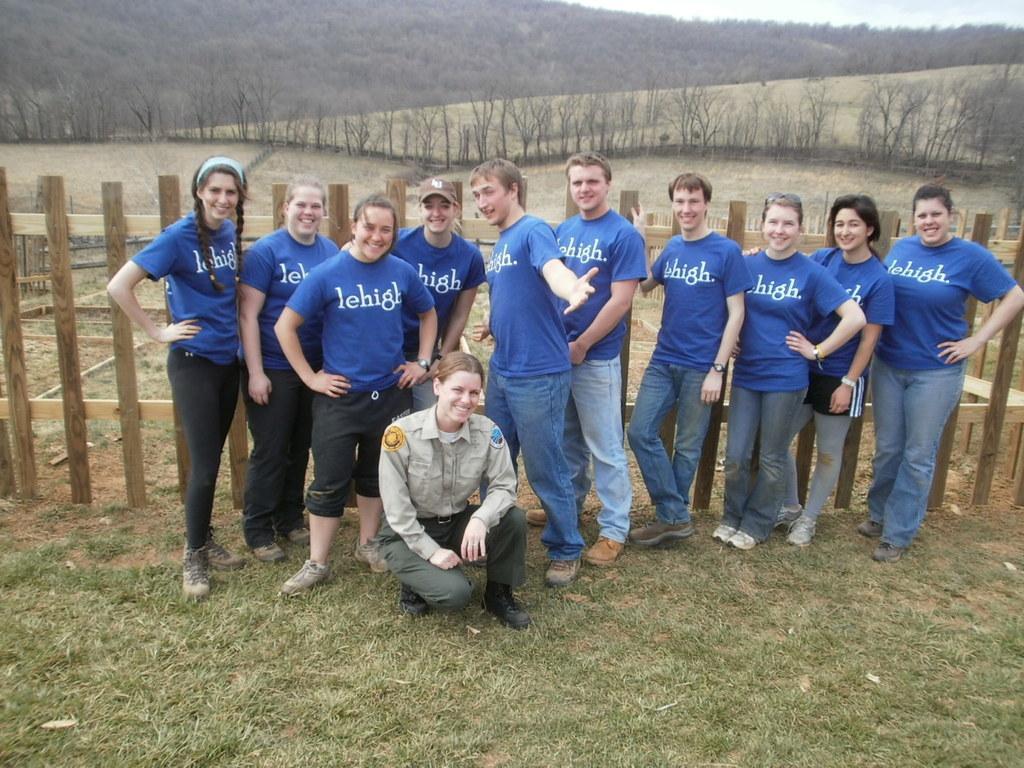Please provide a concise description of this image. In this image we can see some people posing for a photo and we can see the wooden fence behind the people. There are some trees and the mountains in the background. 